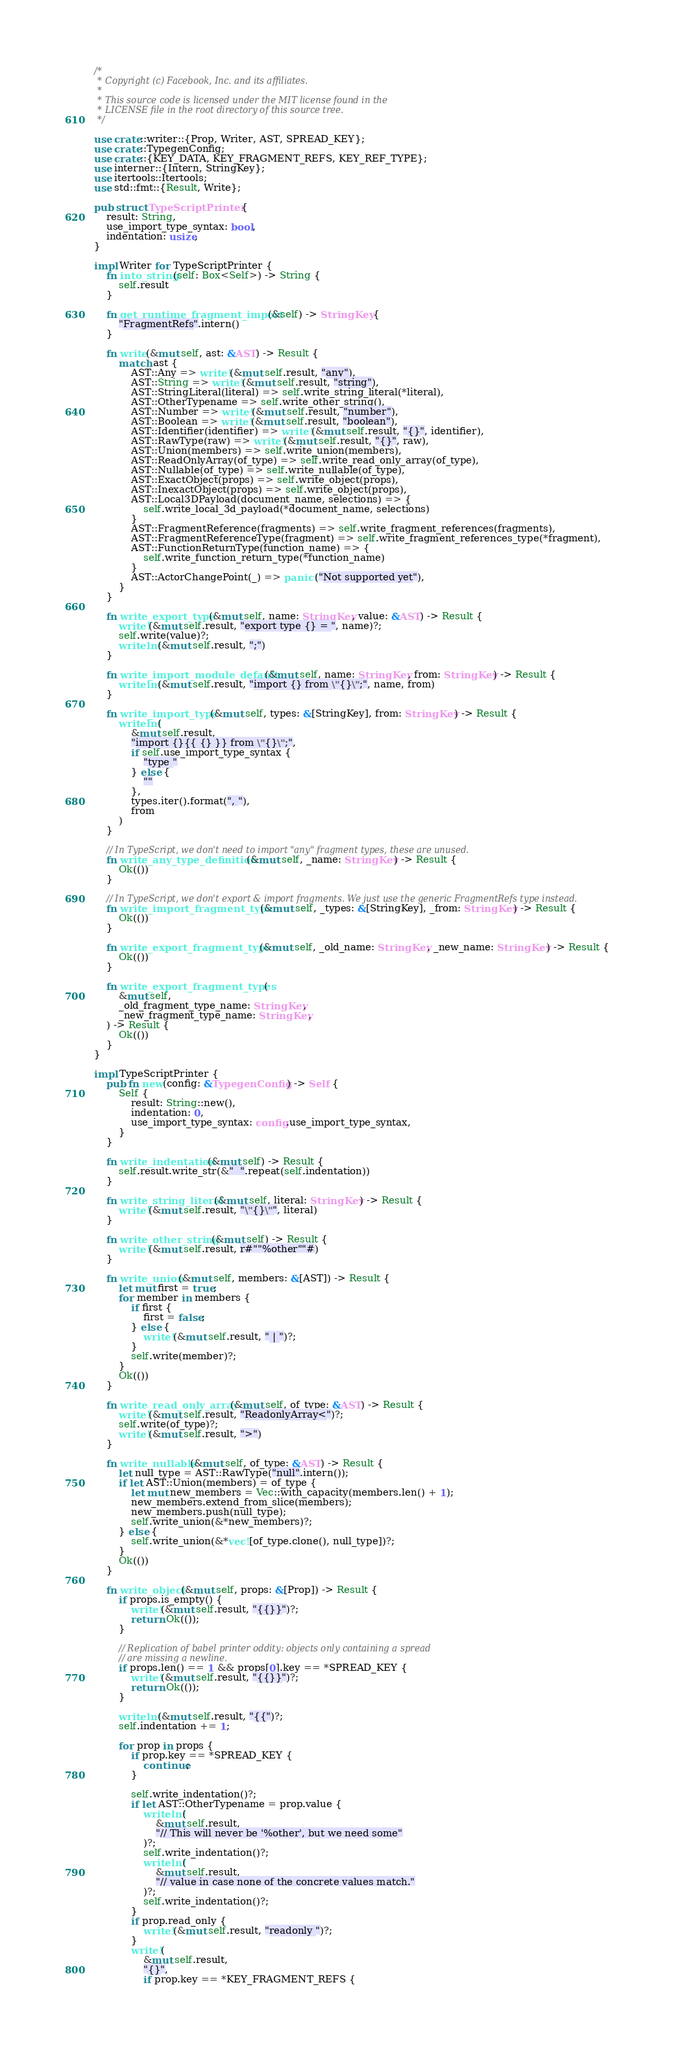Convert code to text. <code><loc_0><loc_0><loc_500><loc_500><_Rust_>/*
 * Copyright (c) Facebook, Inc. and its affiliates.
 *
 * This source code is licensed under the MIT license found in the
 * LICENSE file in the root directory of this source tree.
 */

use crate::writer::{Prop, Writer, AST, SPREAD_KEY};
use crate::TypegenConfig;
use crate::{KEY_DATA, KEY_FRAGMENT_REFS, KEY_REF_TYPE};
use interner::{Intern, StringKey};
use itertools::Itertools;
use std::fmt::{Result, Write};

pub struct TypeScriptPrinter {
    result: String,
    use_import_type_syntax: bool,
    indentation: usize,
}

impl Writer for TypeScriptPrinter {
    fn into_string(self: Box<Self>) -> String {
        self.result
    }

    fn get_runtime_fragment_import(&self) -> StringKey {
        "FragmentRefs".intern()
    }

    fn write(&mut self, ast: &AST) -> Result {
        match ast {
            AST::Any => write!(&mut self.result, "any"),
            AST::String => write!(&mut self.result, "string"),
            AST::StringLiteral(literal) => self.write_string_literal(*literal),
            AST::OtherTypename => self.write_other_string(),
            AST::Number => write!(&mut self.result, "number"),
            AST::Boolean => write!(&mut self.result, "boolean"),
            AST::Identifier(identifier) => write!(&mut self.result, "{}", identifier),
            AST::RawType(raw) => write!(&mut self.result, "{}", raw),
            AST::Union(members) => self.write_union(members),
            AST::ReadOnlyArray(of_type) => self.write_read_only_array(of_type),
            AST::Nullable(of_type) => self.write_nullable(of_type),
            AST::ExactObject(props) => self.write_object(props),
            AST::InexactObject(props) => self.write_object(props),
            AST::Local3DPayload(document_name, selections) => {
                self.write_local_3d_payload(*document_name, selections)
            }
            AST::FragmentReference(fragments) => self.write_fragment_references(fragments),
            AST::FragmentReferenceType(fragment) => self.write_fragment_references_type(*fragment),
            AST::FunctionReturnType(function_name) => {
                self.write_function_return_type(*function_name)
            }
            AST::ActorChangePoint(_) => panic!("Not supported yet"),
        }
    }

    fn write_export_type(&mut self, name: StringKey, value: &AST) -> Result {
        write!(&mut self.result, "export type {} = ", name)?;
        self.write(value)?;
        writeln!(&mut self.result, ";")
    }

    fn write_import_module_default(&mut self, name: StringKey, from: StringKey) -> Result {
        writeln!(&mut self.result, "import {} from \"{}\";", name, from)
    }

    fn write_import_type(&mut self, types: &[StringKey], from: StringKey) -> Result {
        writeln!(
            &mut self.result,
            "import {}{{ {} }} from \"{}\";",
            if self.use_import_type_syntax {
                "type "
            } else {
                ""
            },
            types.iter().format(", "),
            from
        )
    }

    // In TypeScript, we don't need to import "any" fragment types, these are unused.
    fn write_any_type_definition(&mut self, _name: StringKey) -> Result {
        Ok(())
    }

    // In TypeScript, we don't export & import fragments. We just use the generic FragmentRefs type instead.
    fn write_import_fragment_type(&mut self, _types: &[StringKey], _from: StringKey) -> Result {
        Ok(())
    }

    fn write_export_fragment_type(&mut self, _old_name: StringKey, _new_name: StringKey) -> Result {
        Ok(())
    }

    fn write_export_fragment_types(
        &mut self,
        _old_fragment_type_name: StringKey,
        _new_fragment_type_name: StringKey,
    ) -> Result {
        Ok(())
    }
}

impl TypeScriptPrinter {
    pub fn new(config: &TypegenConfig) -> Self {
        Self {
            result: String::new(),
            indentation: 0,
            use_import_type_syntax: config.use_import_type_syntax,
        }
    }

    fn write_indentation(&mut self) -> Result {
        self.result.write_str(&"  ".repeat(self.indentation))
    }

    fn write_string_literal(&mut self, literal: StringKey) -> Result {
        write!(&mut self.result, "\"{}\"", literal)
    }

    fn write_other_string(&mut self) -> Result {
        write!(&mut self.result, r#""%other""#)
    }

    fn write_union(&mut self, members: &[AST]) -> Result {
        let mut first = true;
        for member in members {
            if first {
                first = false;
            } else {
                write!(&mut self.result, " | ")?;
            }
            self.write(member)?;
        }
        Ok(())
    }

    fn write_read_only_array(&mut self, of_type: &AST) -> Result {
        write!(&mut self.result, "ReadonlyArray<")?;
        self.write(of_type)?;
        write!(&mut self.result, ">")
    }

    fn write_nullable(&mut self, of_type: &AST) -> Result {
        let null_type = AST::RawType("null".intern());
        if let AST::Union(members) = of_type {
            let mut new_members = Vec::with_capacity(members.len() + 1);
            new_members.extend_from_slice(members);
            new_members.push(null_type);
            self.write_union(&*new_members)?;
        } else {
            self.write_union(&*vec![of_type.clone(), null_type])?;
        }
        Ok(())
    }

    fn write_object(&mut self, props: &[Prop]) -> Result {
        if props.is_empty() {
            write!(&mut self.result, "{{}}")?;
            return Ok(());
        }

        // Replication of babel printer oddity: objects only containing a spread
        // are missing a newline.
        if props.len() == 1 && props[0].key == *SPREAD_KEY {
            write!(&mut self.result, "{{}}")?;
            return Ok(());
        }

        writeln!(&mut self.result, "{{")?;
        self.indentation += 1;

        for prop in props {
            if prop.key == *SPREAD_KEY {
                continue;
            }

            self.write_indentation()?;
            if let AST::OtherTypename = prop.value {
                writeln!(
                    &mut self.result,
                    "// This will never be '%other', but we need some"
                )?;
                self.write_indentation()?;
                writeln!(
                    &mut self.result,
                    "// value in case none of the concrete values match."
                )?;
                self.write_indentation()?;
            }
            if prop.read_only {
                write!(&mut self.result, "readonly ")?;
            }
            write!(
                &mut self.result,
                "{}",
                if prop.key == *KEY_FRAGMENT_REFS {</code> 